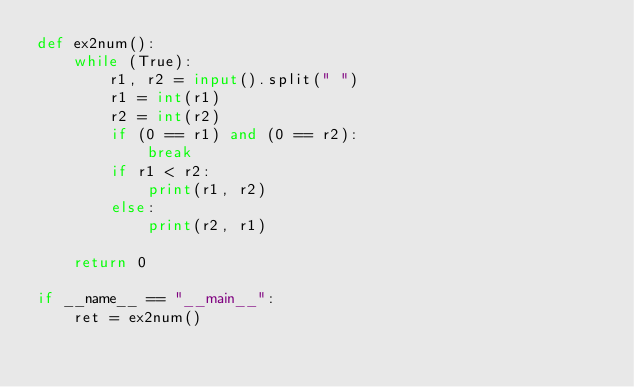Convert code to text. <code><loc_0><loc_0><loc_500><loc_500><_Python_>def ex2num():
    while (True):
        r1, r2 = input().split(" ")
        r1 = int(r1)
        r2 = int(r2)
        if (0 == r1) and (0 == r2):
            break
        if r1 < r2:
            print(r1, r2)
        else:
            print(r2, r1)

    return 0

if __name__ == "__main__":
    ret = ex2num()
</code> 